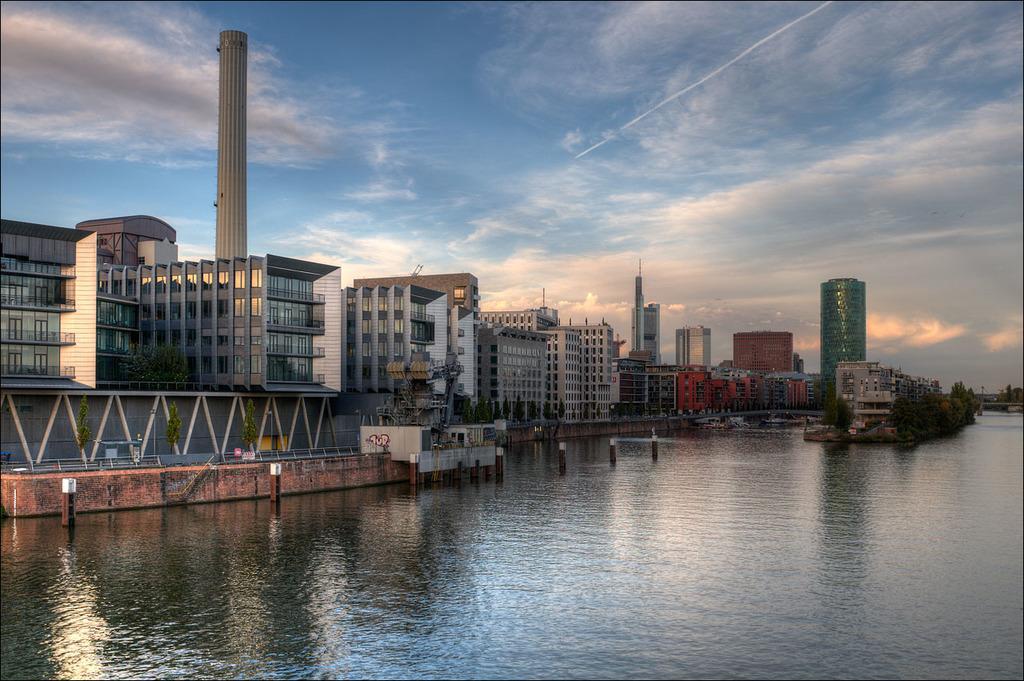Could you give a brief overview of what you see in this image? In this image I can see the water. In the background I can see few trees in green color, few buildings and the sky is in blue and white color. 